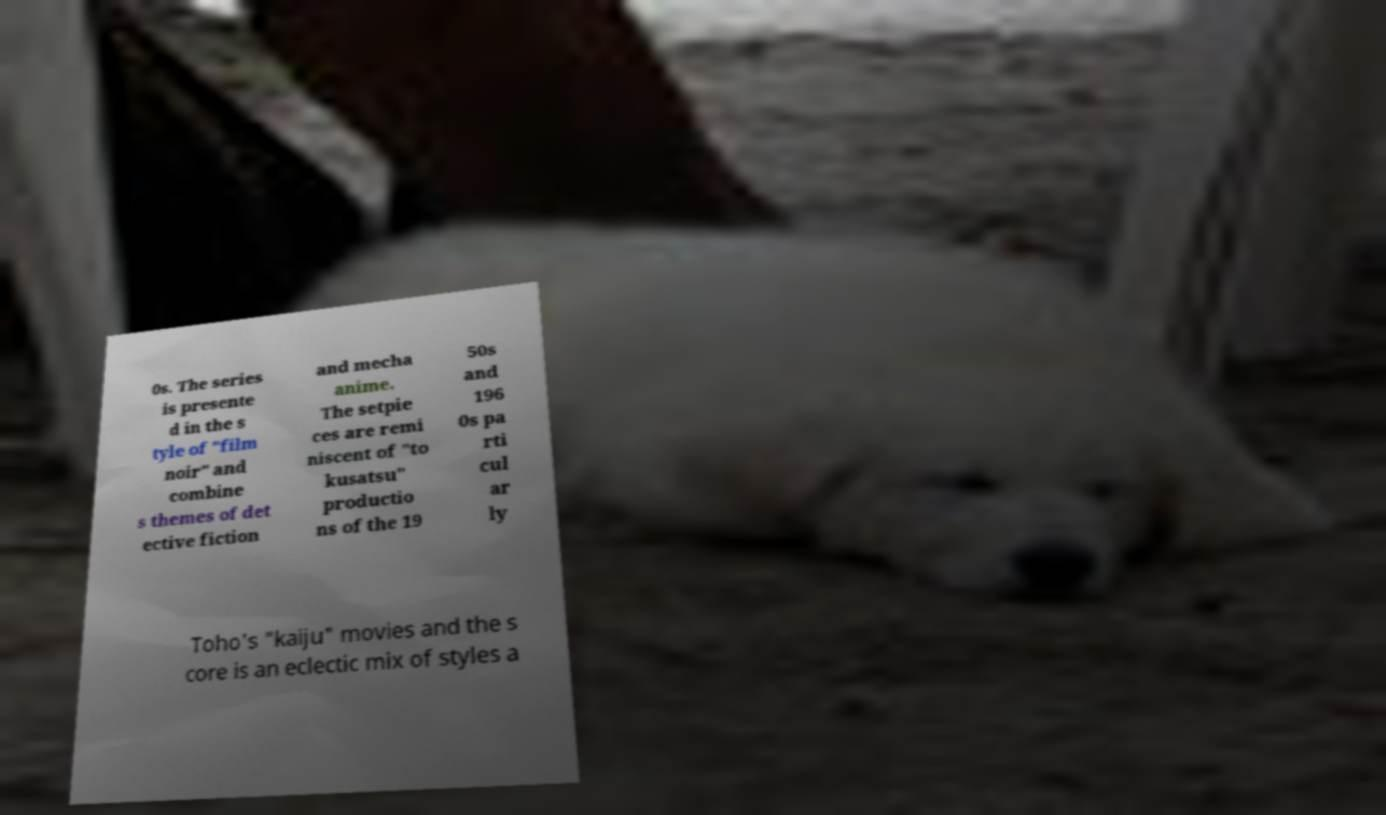I need the written content from this picture converted into text. Can you do that? 0s. The series is presente d in the s tyle of "film noir" and combine s themes of det ective fiction and mecha anime. The setpie ces are remi niscent of "to kusatsu" productio ns of the 19 50s and 196 0s pa rti cul ar ly Toho's "kaiju" movies and the s core is an eclectic mix of styles a 